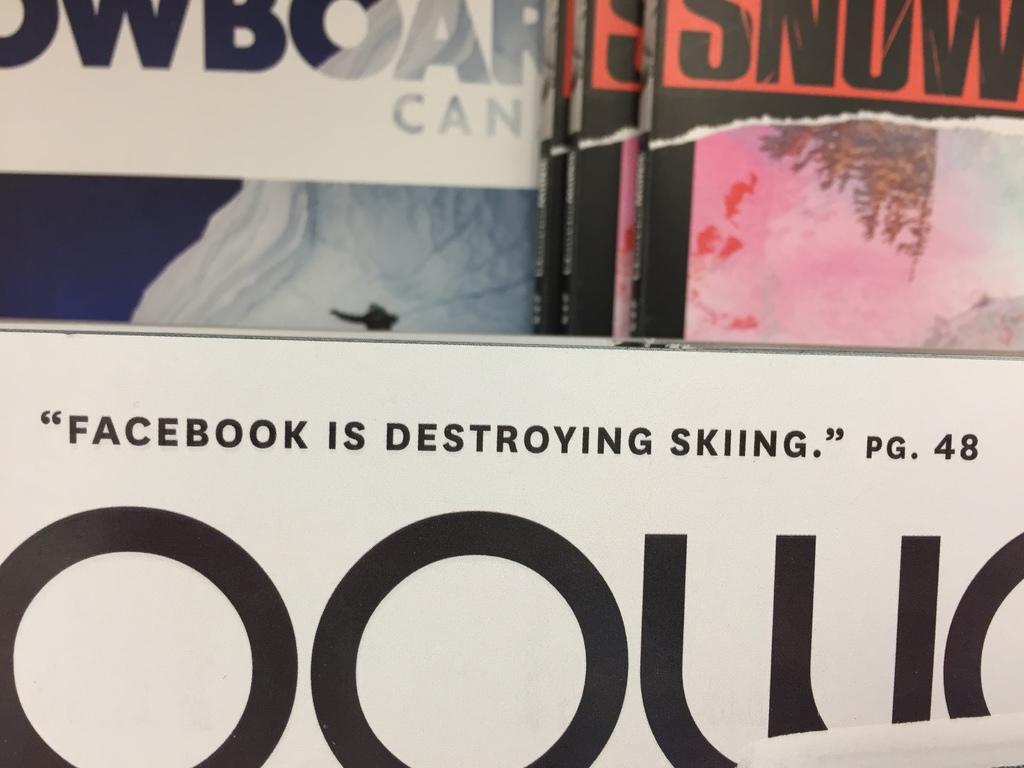<image>
Offer a succinct explanation of the picture presented. A magazine with the article "Facebook is Destroying Skiing" listed on the cover 